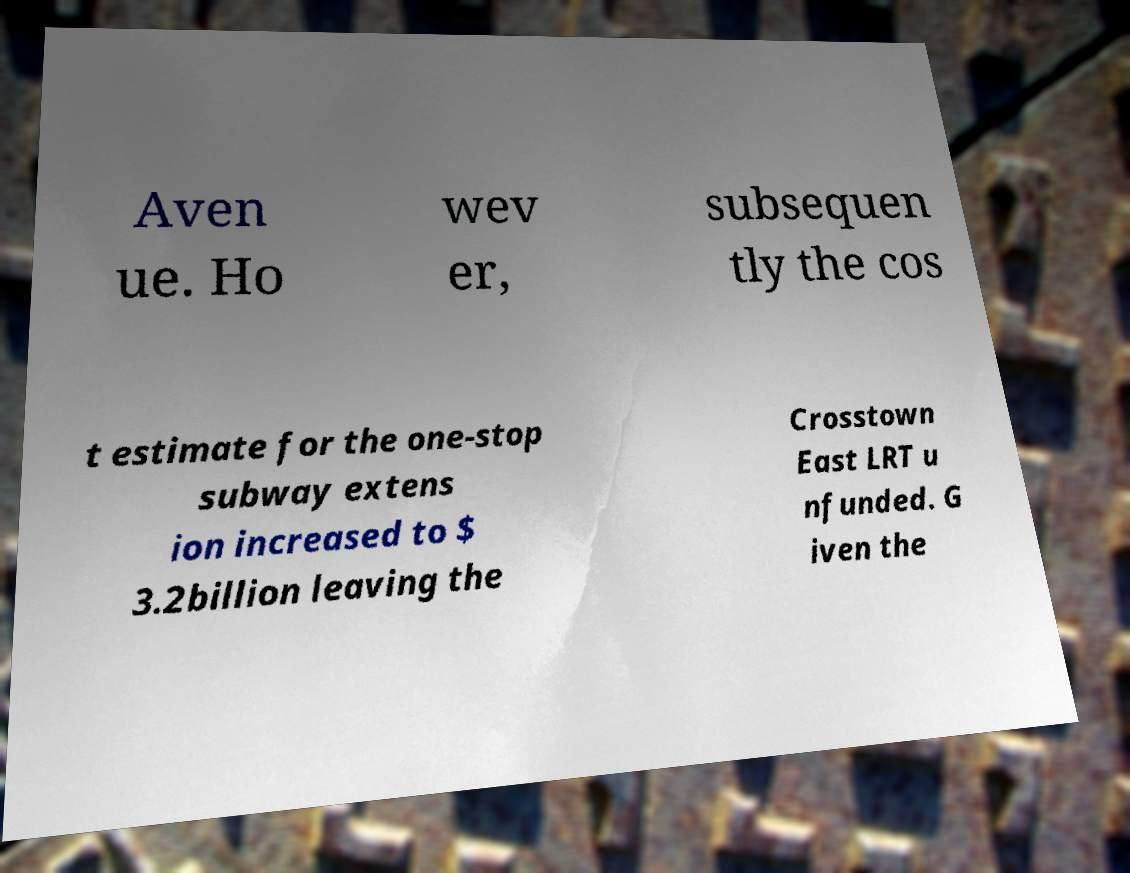Please read and relay the text visible in this image. What does it say? Aven ue. Ho wev er, subsequen tly the cos t estimate for the one-stop subway extens ion increased to $ 3.2billion leaving the Crosstown East LRT u nfunded. G iven the 